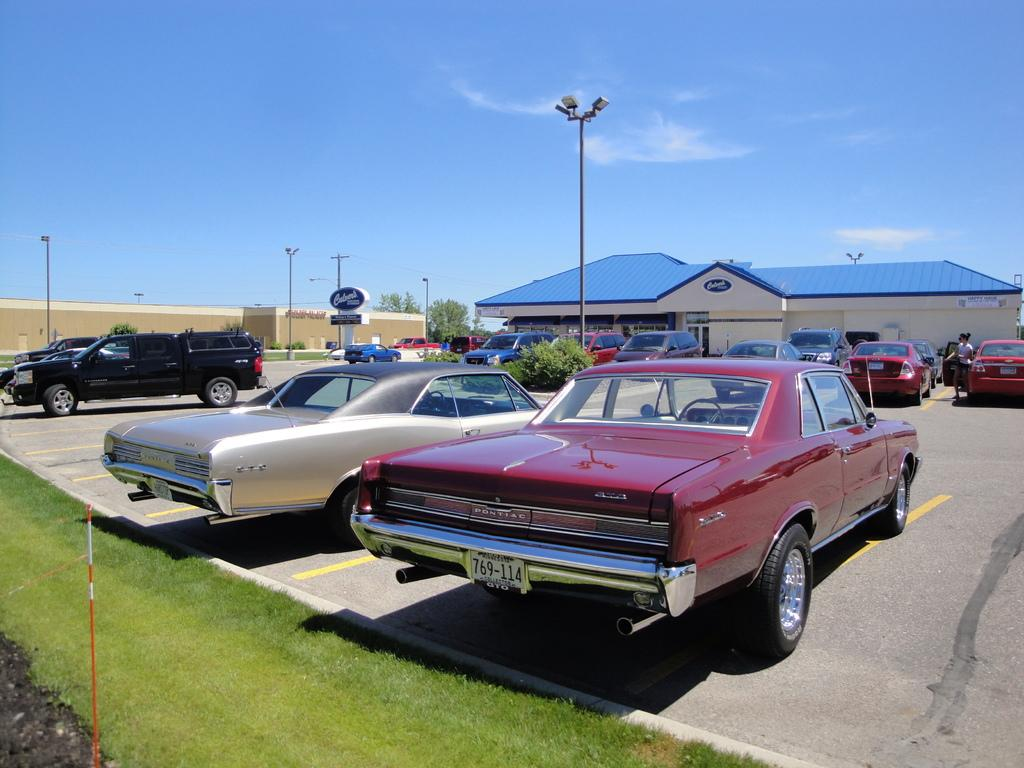What can be seen parked on the road in the image? There are vehicles parked on the road in the image. What type of barrier surrounds the area in the image? The place has a compound wall. What type of vegetation is present near the compound wall? Grass and plants are present near the compound wall. What type of lighting is present in the image? There is a street light in the image. What is the color of the sky in the image? The sky is blue in the image. How many fans are visible in the image? There are no fans present in the image. What type of boundary is present near the grass in the image? There is no specific boundary mentioned near the grass in the image; only a compound wall is mentioned. What type of flower is present near the plants in the image? There is no flower mentioned in the image; only grass and plants are mentioned. 